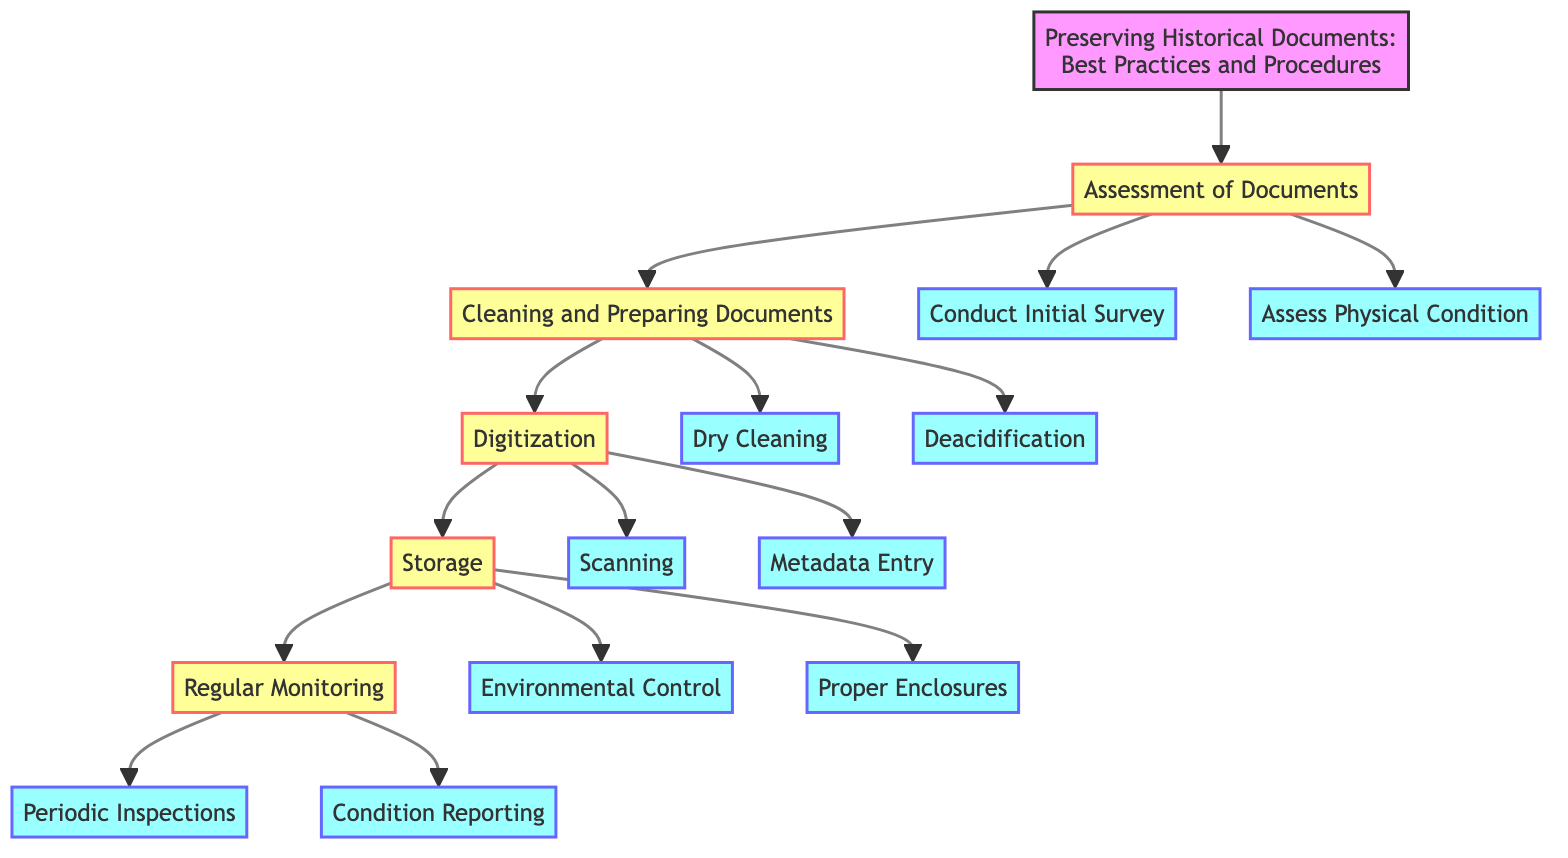What is the first step in the process? The first step is identified in the diagram as "Assessment of Documents". This is the first node directly connected to the title.
Answer: Assessment of Documents How many actions follow the "Digitization" step? The "Digitization" step has two actions: "Scanning" and "Metadata Entry". This can be counted by examining the connections under the "Digitization" node.
Answer: 2 What is the action associated with "Cleaning and Preparing Documents"? The actions listed under "Cleaning and Preparing Documents" are "Dry Cleaning" and "Deacidification". Observing the flowchart, these actions are directly linked to this step.
Answer: Dry Cleaning, Deacidification What is the last step before "Regular Monitoring"? The last step before "Regular Monitoring" in the flowchart is "Storage", which is the last connecting node prior to "Regular Monitoring".
Answer: Storage Which specific action involves checking document conditions semi-annually? The action that involves checking document conditions every six months is "Periodic Inspections". This is explicitly stated as part of the "Regular Monitoring" step.
Answer: Periodic Inspections What is the recommended temperature range for environmental control? The recommended temperature range for environmental control is between 18-22 degrees Celsius, as indicated under the "Environmental Control" action.
Answer: 18-22°C What tools are suggested for conducting an initial survey of documents? The tools suggested for conducting an initial survey are "PastPerfect" and "Archivist Toolkit". These tools are mentioned directly under the corresponding action.
Answer: PastPerfect, Archivist Toolkit Which step focuses on making documents accessible through digitization? The step that focuses on digitizing documents for preservation and access is "Digitization". This is directly indicated in the title of that section.
Answer: Digitization How often should inspections be conducted according to the flowchart? Inspections should be conducted every six months, as stated in the "Periodic Inspections" action under "Regular Monitoring".
Answer: Every six months 